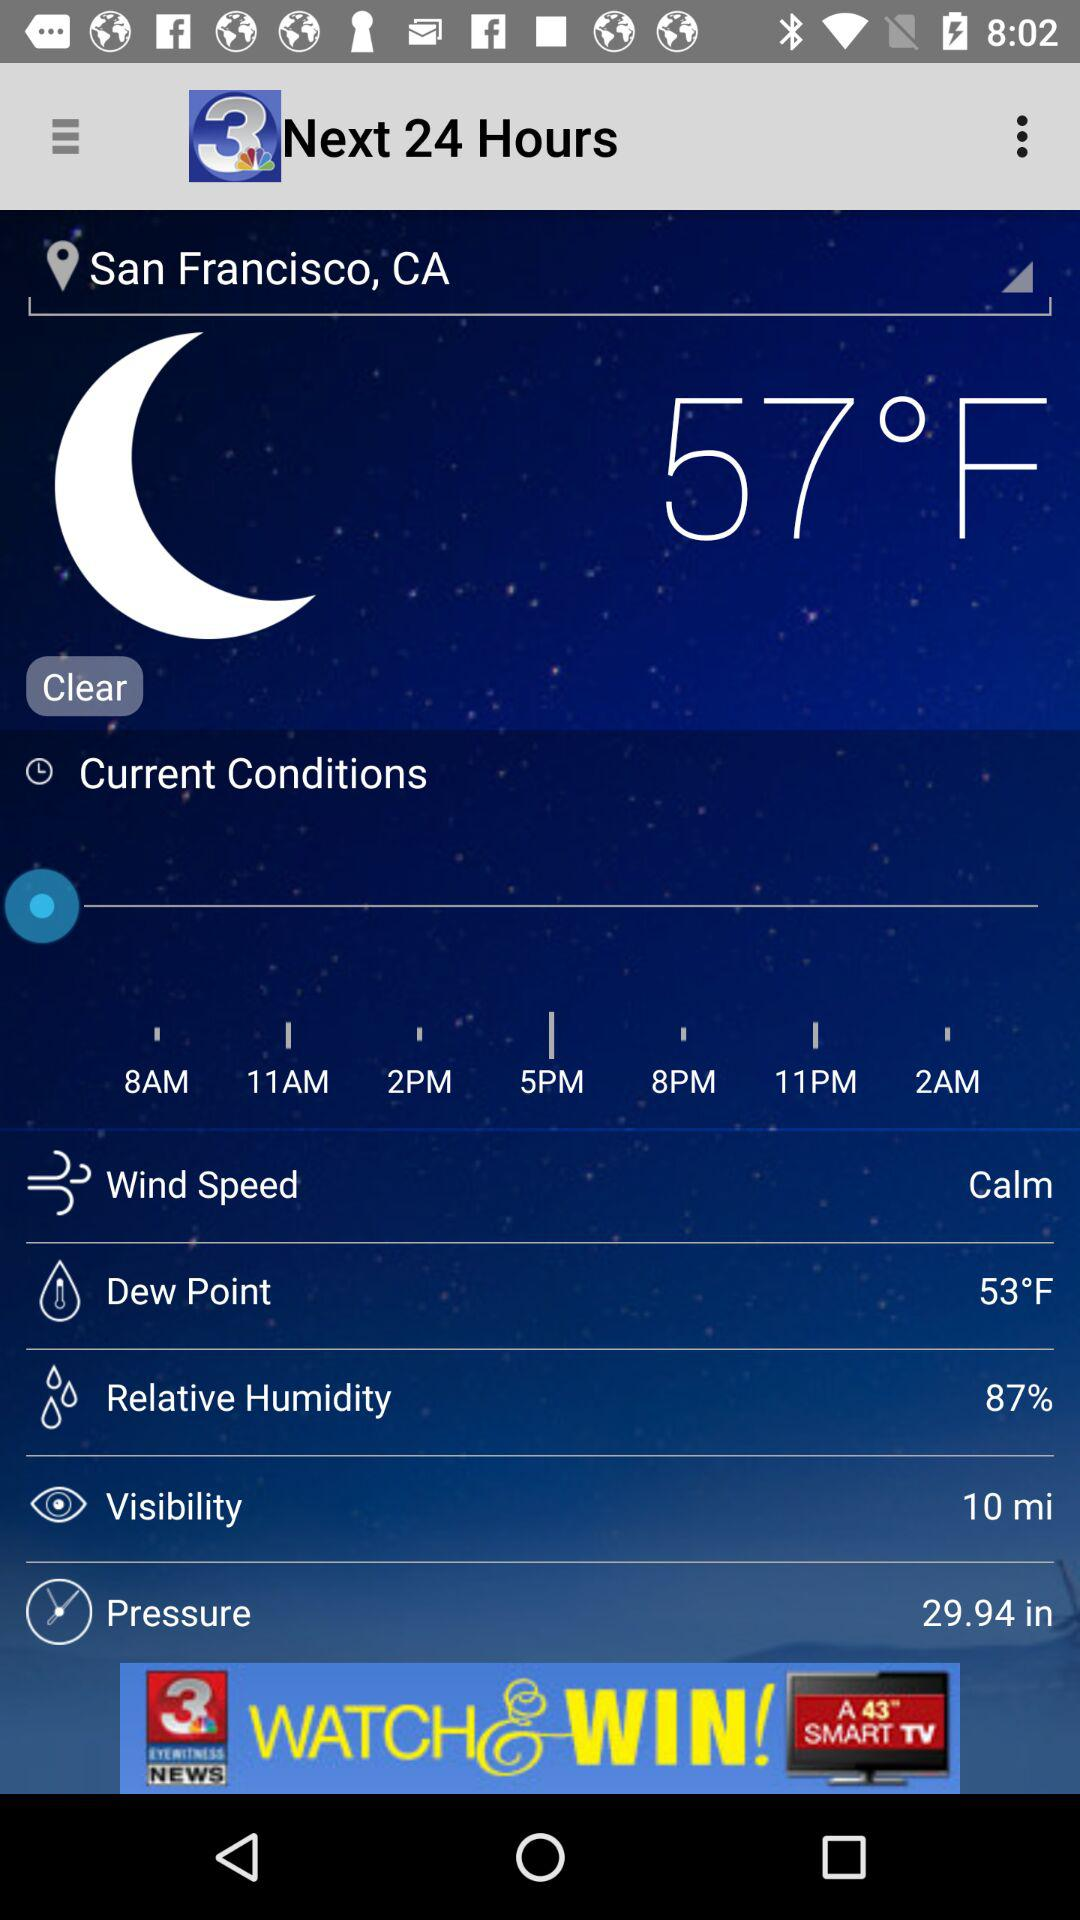What is the location? The location is San Francisco, CA. 